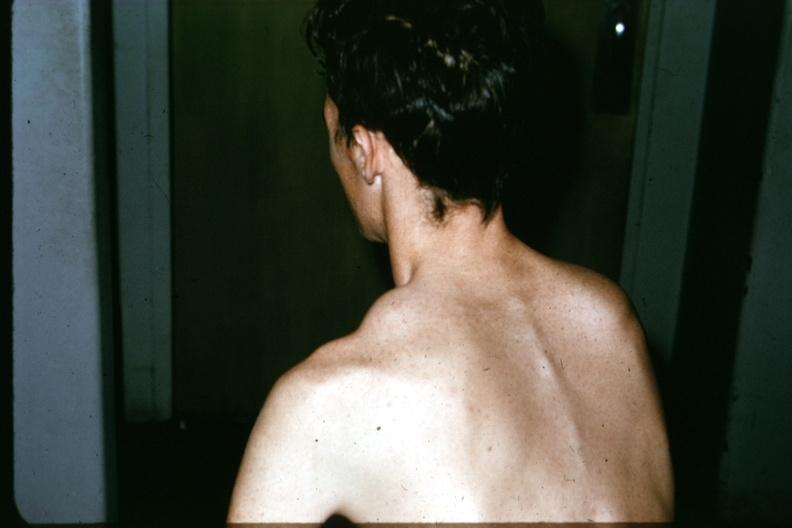does this image show patient before surgery lesion in clavicle?
Answer the question using a single word or phrase. Yes 